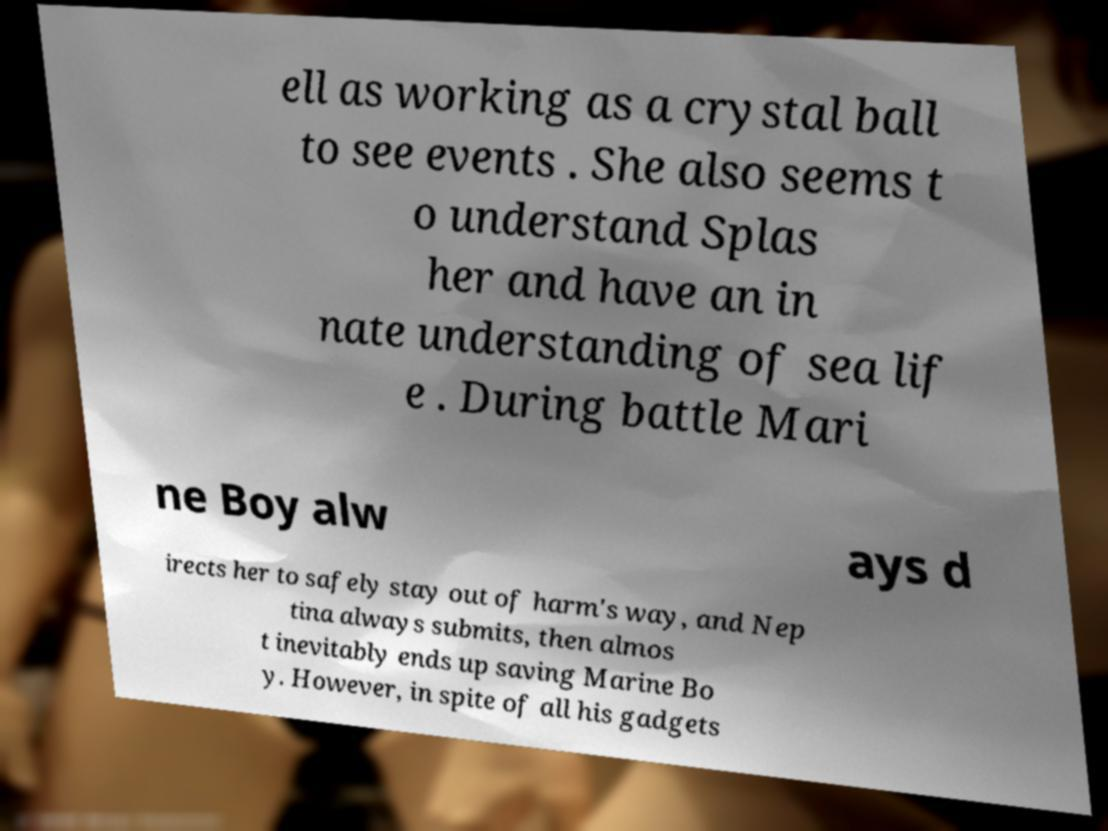Could you assist in decoding the text presented in this image and type it out clearly? ell as working as a crystal ball to see events . She also seems t o understand Splas her and have an in nate understanding of sea lif e . During battle Mari ne Boy alw ays d irects her to safely stay out of harm's way, and Nep tina always submits, then almos t inevitably ends up saving Marine Bo y. However, in spite of all his gadgets 